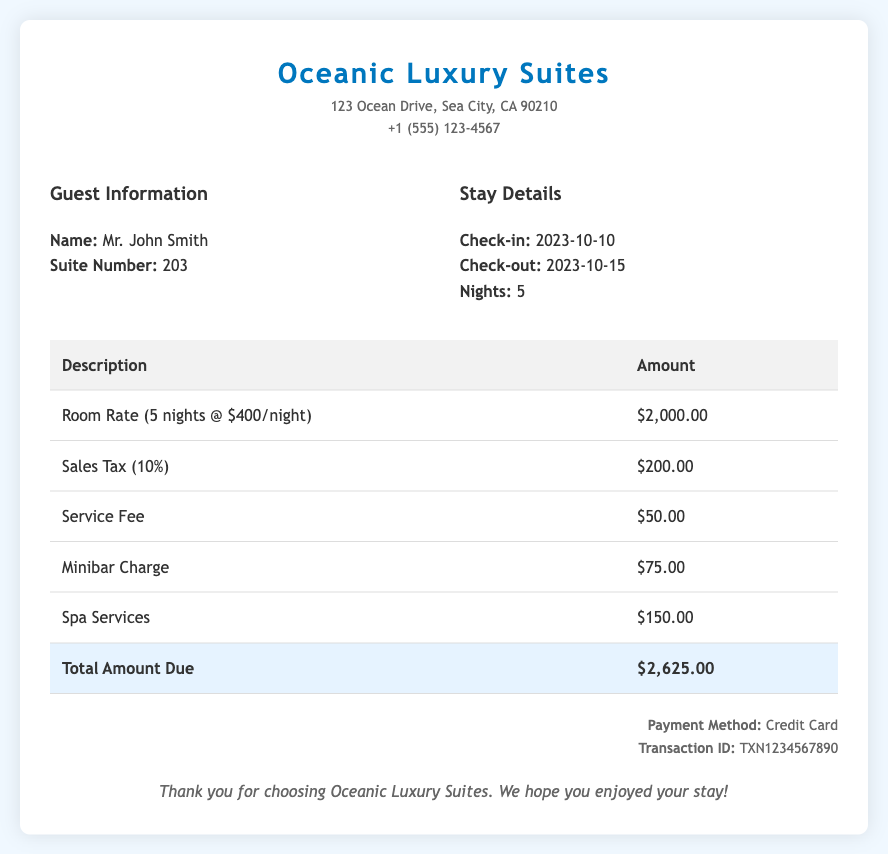What is the name of the guest? The guest's name is listed at the top of the bill under Guest Information.
Answer: Mr. John Smith How many nights did the guest stay? The number of nights is mentioned in the Stay Details section of the bill.
Answer: 5 What is the room rate per night? The room rate per night can be derived from the calculation provided for the total room rate.
Answer: $400 What is the total amount due? The total amount due is clearly stated at the bottom of the bill.
Answer: $2,625.00 How much was charged for the minibar? The charge for the minibar is listed among the additional fees in the bill's table.
Answer: $75.00 What is the sales tax percentage applied? The sales tax percentage is indicated clearly in the description of the tax charge.
Answer: 10% What is the payment method used? The payment method is specified in the Payment Information section of the bill.
Answer: Credit Card What services were included in additional fees? The additional fees include charges for services mentioned in the table of the bill.
Answer: Service Fee, Minibar Charge, Spa Services What was the check-out date? The check-out date is part of the Stay Details section.
Answer: 2023-10-15 